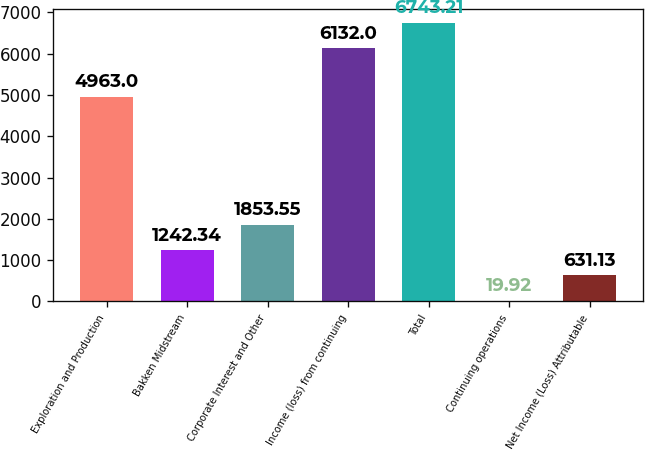Convert chart. <chart><loc_0><loc_0><loc_500><loc_500><bar_chart><fcel>Exploration and Production<fcel>Bakken Midstream<fcel>Corporate Interest and Other<fcel>Income (loss) from continuing<fcel>Total<fcel>Continuing operations<fcel>Net Income (Loss) Attributable<nl><fcel>4963<fcel>1242.34<fcel>1853.55<fcel>6132<fcel>6743.21<fcel>19.92<fcel>631.13<nl></chart> 